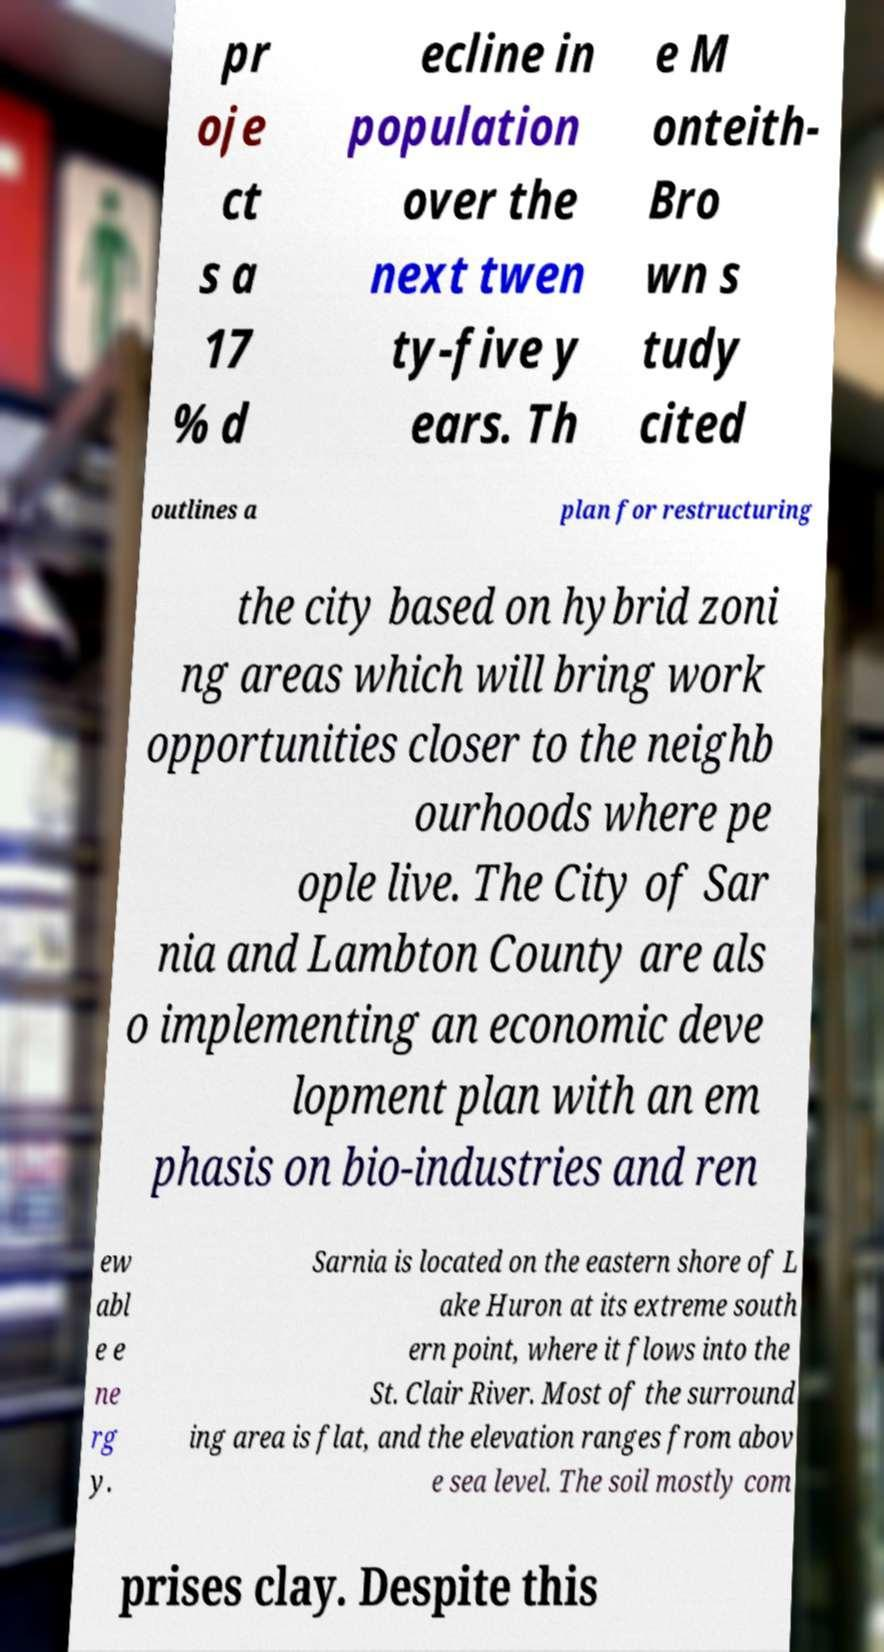There's text embedded in this image that I need extracted. Can you transcribe it verbatim? pr oje ct s a 17 % d ecline in population over the next twen ty-five y ears. Th e M onteith- Bro wn s tudy cited outlines a plan for restructuring the city based on hybrid zoni ng areas which will bring work opportunities closer to the neighb ourhoods where pe ople live. The City of Sar nia and Lambton County are als o implementing an economic deve lopment plan with an em phasis on bio-industries and ren ew abl e e ne rg y. Sarnia is located on the eastern shore of L ake Huron at its extreme south ern point, where it flows into the St. Clair River. Most of the surround ing area is flat, and the elevation ranges from abov e sea level. The soil mostly com prises clay. Despite this 